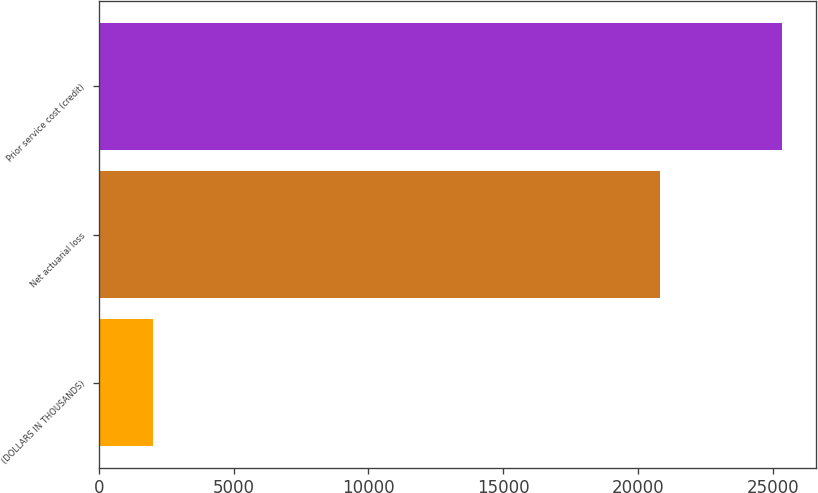Convert chart to OTSL. <chart><loc_0><loc_0><loc_500><loc_500><bar_chart><fcel>(DOLLARS IN THOUSANDS)<fcel>Net actuarial loss<fcel>Prior service cost (credit)<nl><fcel>2017<fcel>20810<fcel>25330<nl></chart> 